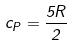Convert formula to latex. <formula><loc_0><loc_0><loc_500><loc_500>c _ { P } = \frac { 5 R } { 2 }</formula> 